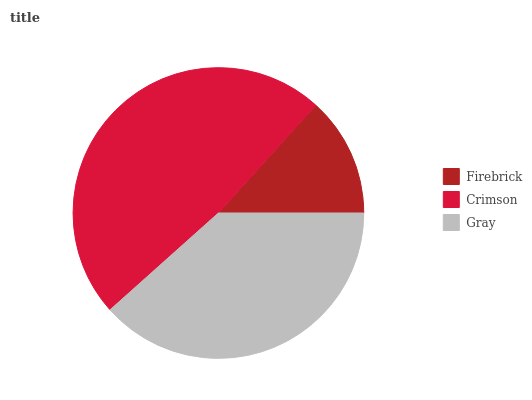Is Firebrick the minimum?
Answer yes or no. Yes. Is Crimson the maximum?
Answer yes or no. Yes. Is Gray the minimum?
Answer yes or no. No. Is Gray the maximum?
Answer yes or no. No. Is Crimson greater than Gray?
Answer yes or no. Yes. Is Gray less than Crimson?
Answer yes or no. Yes. Is Gray greater than Crimson?
Answer yes or no. No. Is Crimson less than Gray?
Answer yes or no. No. Is Gray the high median?
Answer yes or no. Yes. Is Gray the low median?
Answer yes or no. Yes. Is Crimson the high median?
Answer yes or no. No. Is Crimson the low median?
Answer yes or no. No. 